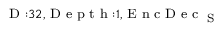<formula> <loc_0><loc_0><loc_500><loc_500>_ { D \colon 3 2 , D e p t h \colon 1 , E n c D e c _ { S } }</formula> 